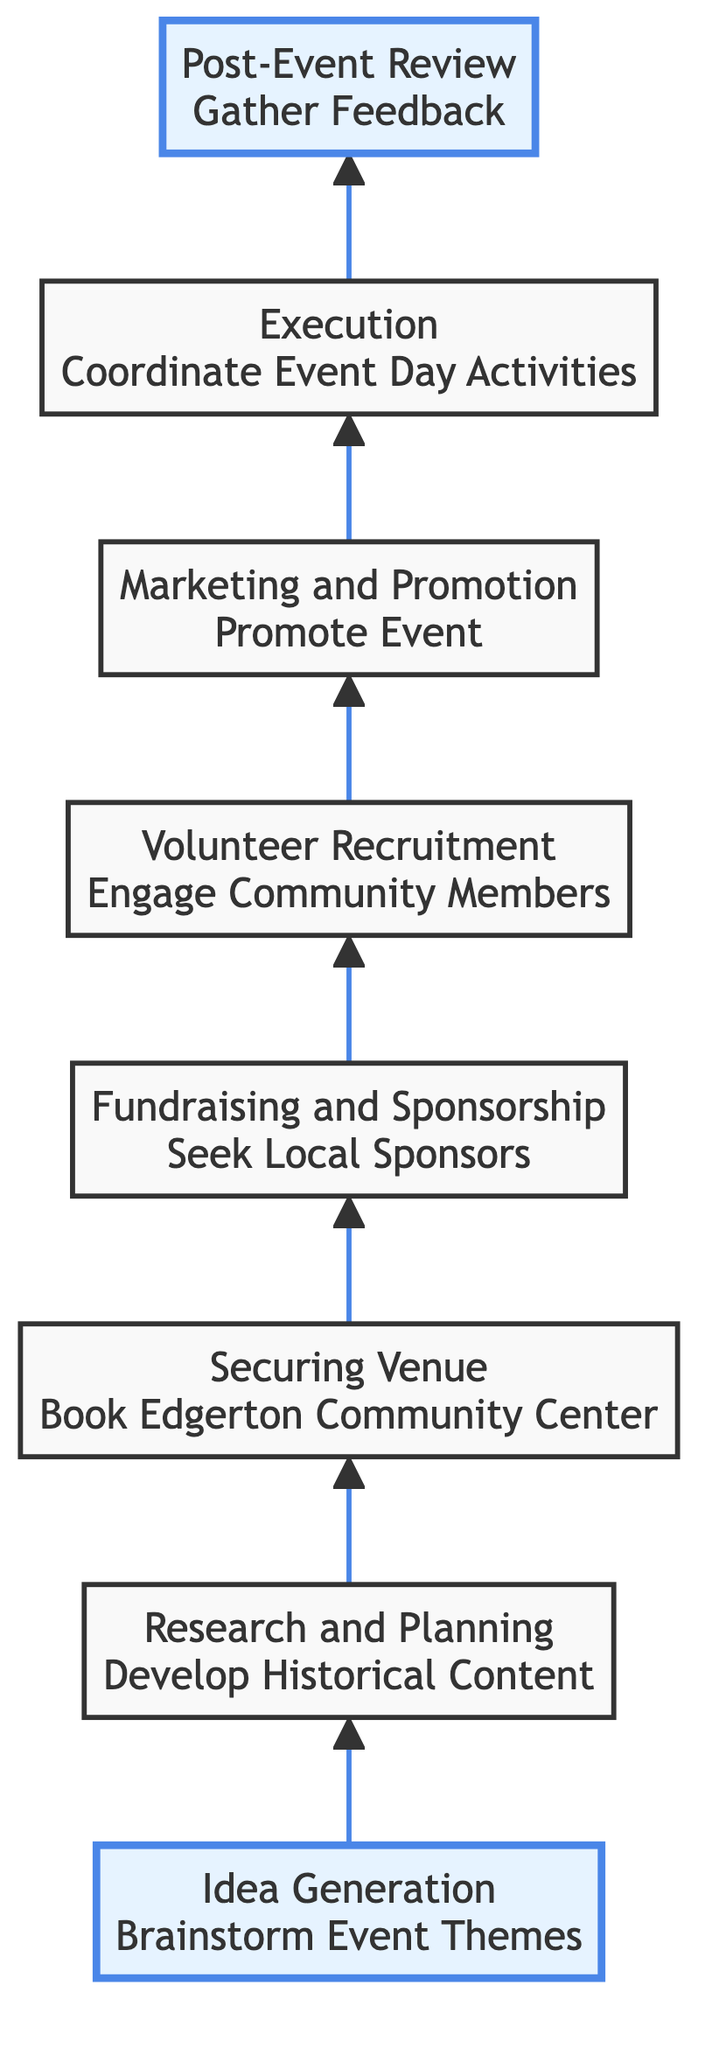What is the first step in the process? The first step in the process is located at the bottom of the flow chart. It is labeled "Idea Generation".
Answer: Idea Generation How many steps are there in total? By counting each distinct step from the bottom to the top in the diagram, we can see there are eight steps in total.
Answer: 8 Which step comes after "Marketing and Promotion"? Following the arrows in the diagram, the step that comes after "Marketing and Promotion" is "Execution".
Answer: Execution What action is associated with "Securing Venue"? Looking at the specifics of the "Securing Venue" step in the diagram, it outlines the action as "Book Edgerton Community Center".
Answer: Book Edgerton Community Center What step involves collecting feedback? The topmost step indicates that "Post-Event Review" involves gathering feedback from attendees and volunteers.
Answer: Post-Event Review Which two steps are directly connected? By observing the flow of the arrows in the diagram, "Fundraising and Sponsorship" and "Volunteer Recruitment" are directly connected to each other, showing a direct sequence.
Answer: Fundraising and Sponsorship, Volunteer Recruitment What is the last action in the process? The last action in the process, as indicated by the topmost box in the flow diagram, is "Gather Feedback".
Answer: Gather Feedback What is a common theme in the steps of the diagram? Each step in the diagram is focused on the preparation and execution of a historical community event, indicating a sequential development from conception to review.
Answer: Preparation and execution of a historical community event 